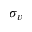<formula> <loc_0><loc_0><loc_500><loc_500>\sigma _ { v }</formula> 